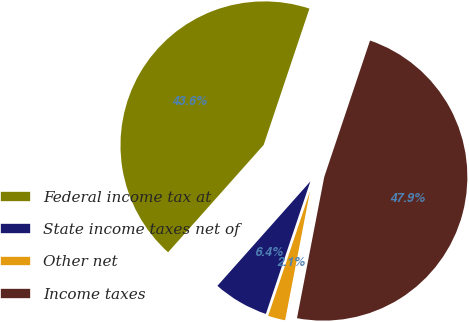Convert chart to OTSL. <chart><loc_0><loc_0><loc_500><loc_500><pie_chart><fcel>Federal income tax at<fcel>State income taxes net of<fcel>Other net<fcel>Income taxes<nl><fcel>43.58%<fcel>6.42%<fcel>2.12%<fcel>47.88%<nl></chart> 